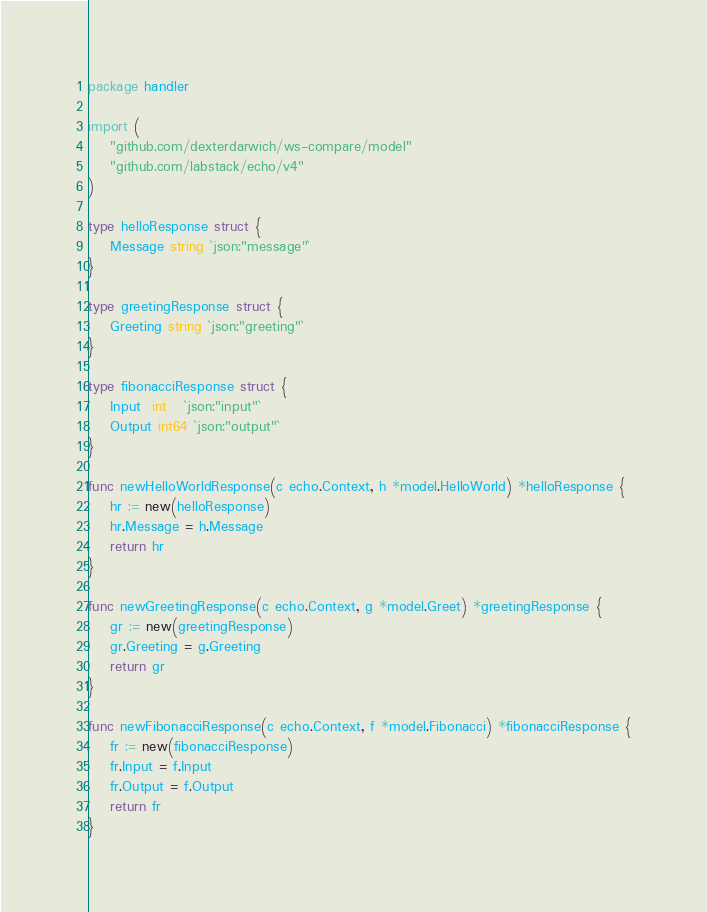<code> <loc_0><loc_0><loc_500><loc_500><_Go_>package handler

import (
	"github.com/dexterdarwich/ws-compare/model"
	"github.com/labstack/echo/v4"
)

type helloResponse struct {
	Message string `json:"message"`
}

type greetingResponse struct {
	Greeting string `json:"greeting"`
}

type fibonacciResponse struct {
	Input  int   `json:"input"`
	Output int64 `json:"output"`
}

func newHelloWorldResponse(c echo.Context, h *model.HelloWorld) *helloResponse {
	hr := new(helloResponse)
	hr.Message = h.Message
	return hr
}

func newGreetingResponse(c echo.Context, g *model.Greet) *greetingResponse {
	gr := new(greetingResponse)
	gr.Greeting = g.Greeting
	return gr
}

func newFibonacciResponse(c echo.Context, f *model.Fibonacci) *fibonacciResponse {
	fr := new(fibonacciResponse)
	fr.Input = f.Input
	fr.Output = f.Output
	return fr
}
</code> 